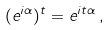Convert formula to latex. <formula><loc_0><loc_0><loc_500><loc_500>( e ^ { i \alpha } ) ^ { t } = e ^ { i t \alpha } \, ,</formula> 